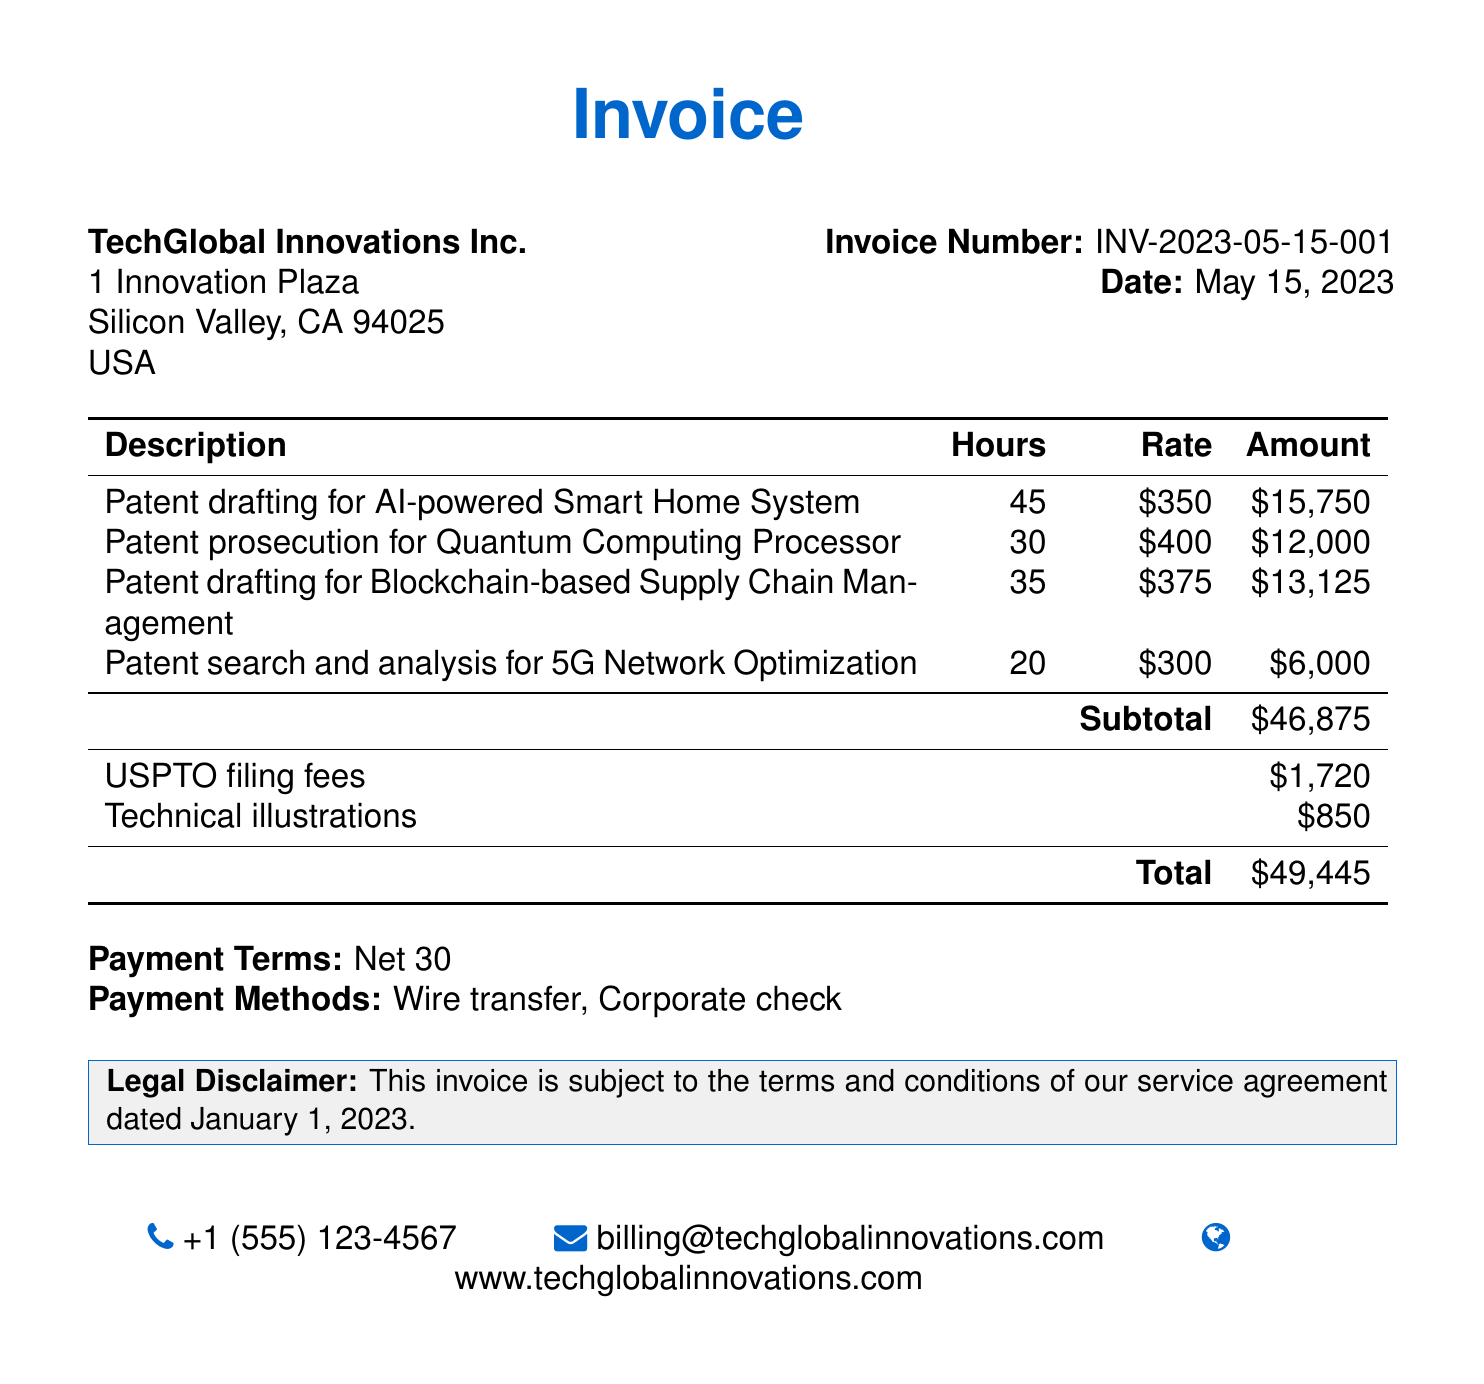What is the invoice number? The invoice number is stated in the document as INV-2023-05-15-001.
Answer: INV-2023-05-15-001 What is the total amount due? The total amount due is mentioned at the bottom of the invoice, which is $49,445.
Answer: $49,445 How many hours were spent on patent drafting for Blockchain-based Supply Chain Management? The document specifies that 35 hours were spent on this service.
Answer: 35 What is the rate charged for patent prosecution for Quantum Computing Processor? The rate for this service is stated as $400 per hour.
Answer: $400 What are the payment terms? The payment terms are mentioned as Net 30.
Answer: Net 30 What is the amount for technical illustrations? The amount for technical illustrations is mentioned in the document as $850.
Answer: $850 How much was the subtotal before additional fees? The subtotal before additional fees is specifically stated as $46,875.
Answer: $46,875 How many hours were dedicated to patent search and analysis for 5G Network Optimization? The document specifies 20 hours for this service.
Answer: 20 What is the company name of the invoicing party? The company name is TechGlobal Innovations Inc.
Answer: TechGlobal Innovations Inc 